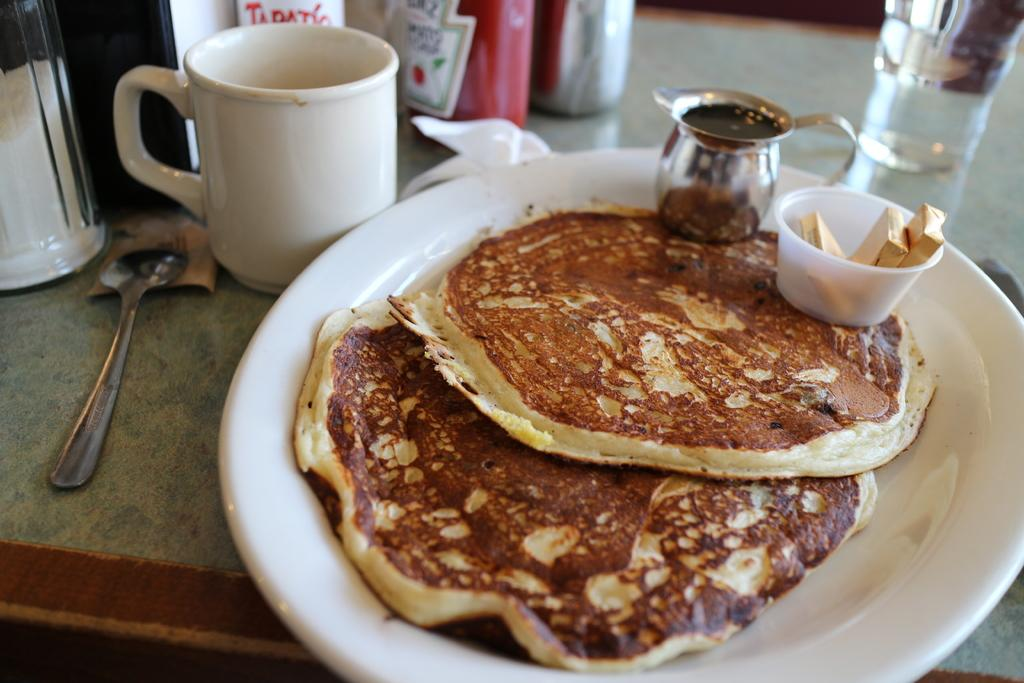What is on the food plate in the image? The food plate contains food. What type of sweets can be seen in the image? There are chocolates in the image. What is the cup in the image used for? The cup is likely used for holding a beverage. What utensil is present in the image? There is a spoon in the image. What is the glass of water in the image used for? The glass of water is likely used for drinking. What other objects are present on the table in the image? There are other objects on the table in the image, but their specific details are not mentioned in the provided facts. How many plants are visible on the table in the image? There is no mention of plants in the provided facts, so we cannot determine if any are present in the image. How many boys are visible in the image? There is no mention of boys in the provided facts, so we cannot determine if any are present in the image. 